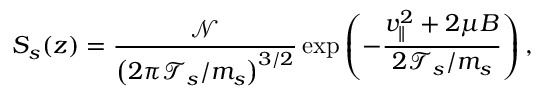Convert formula to latex. <formula><loc_0><loc_0><loc_500><loc_500>S _ { s } ( z ) = \frac { \mathcal { N } } { \left ( 2 \pi \mathcal { T } _ { s } / m _ { s } \right ) ^ { 3 / 2 } } \exp \left ( - \frac { v _ { \| } ^ { 2 } + 2 \mu B } { 2 \mathcal { T } _ { s } / m _ { s } } \right ) ,</formula> 